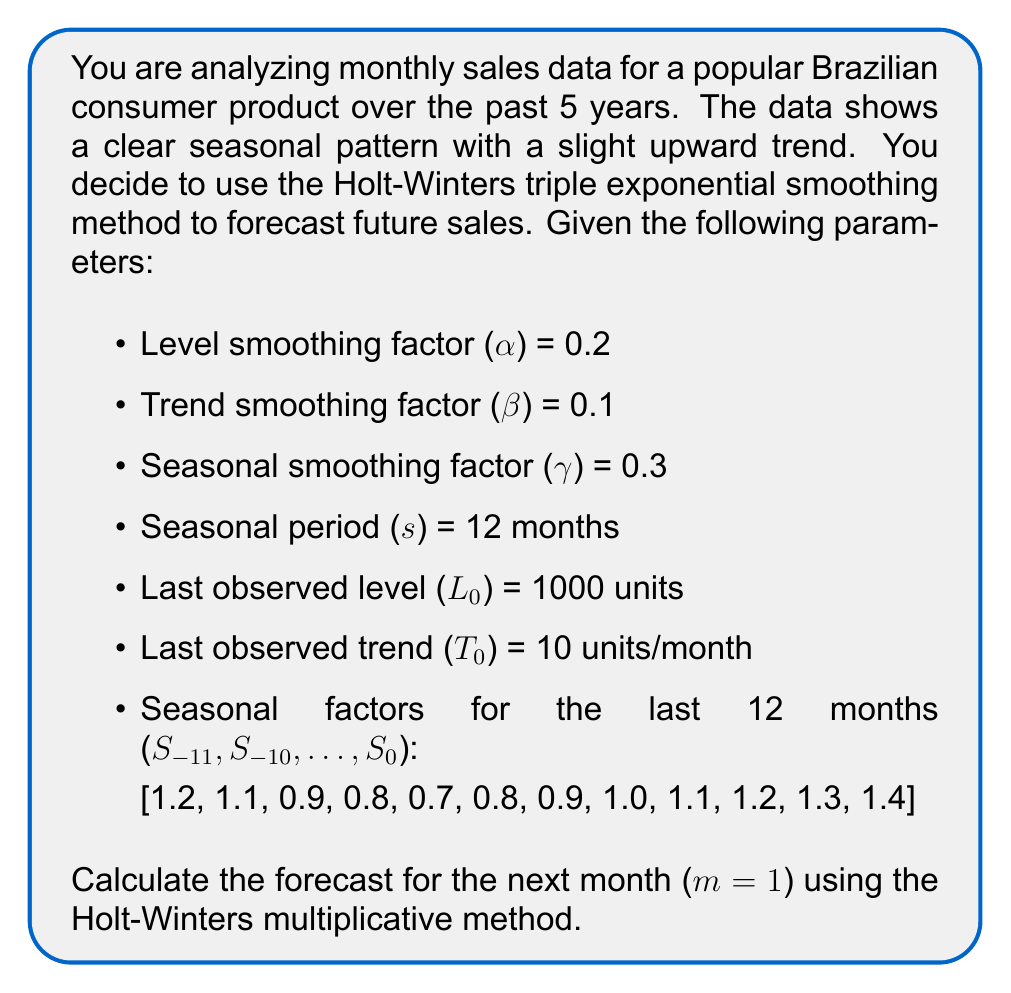Can you answer this question? To forecast using the Holt-Winters multiplicative method, we need to apply the following formulas:

1. Forecast equation:
   $$F_{m} = (L_0 + mT_0) \cdot S_{-s+m}$$

   Where:
   $F_m$ is the forecast for m periods ahead
   $L_0$ is the last estimated level
   $T_0$ is the last estimated trend
   $S_{-s+m}$ is the seasonal factor for the forecasted period

2. For our case, we're forecasting one month ahead (m = 1), so we use:
   $$F_1 = (L_0 + 1 \cdot T_0) \cdot S_{-11}$$

3. Substituting the given values:
   $L_0 = 1000$
   $T_0 = 10$
   $S_{-11} = 1.2$ (first value in the seasonal factors list)

4. Calculating:
   $$F_1 = (1000 + 1 \cdot 10) \cdot 1.2$$
   $$F_1 = 1010 \cdot 1.2$$
   $$F_1 = 1212$$

Therefore, the forecast for the next month is 1212 units.

Note: In a real-world scenario, after each new observation, you would update the level, trend, and seasonal factors using the Holt-Winters updating equations before making the next forecast.
Answer: 1212 units 